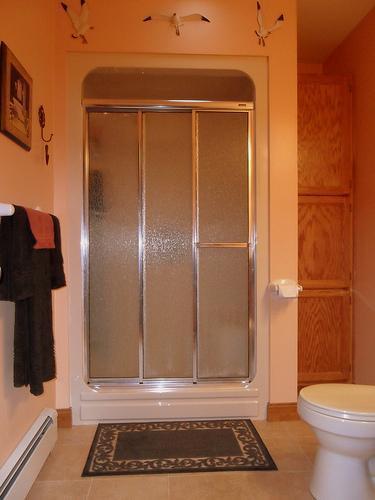How many birds are in the room?
Give a very brief answer. 3. 